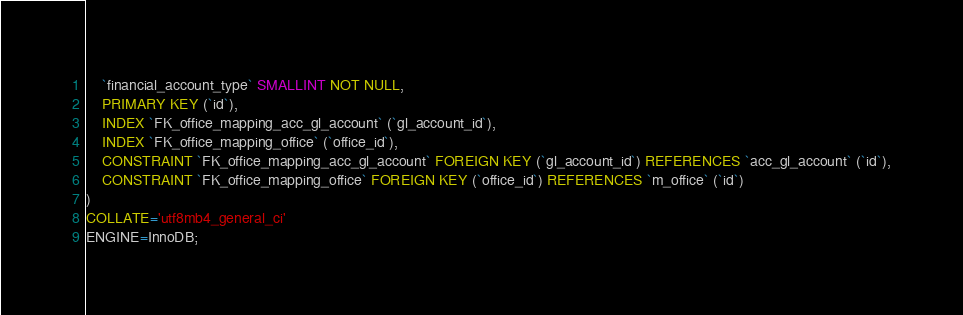Convert code to text. <code><loc_0><loc_0><loc_500><loc_500><_SQL_>	`financial_account_type` SMALLINT NOT NULL,
	PRIMARY KEY (`id`),
	INDEX `FK_office_mapping_acc_gl_account` (`gl_account_id`),
	INDEX `FK_office_mapping_office` (`office_id`),
	CONSTRAINT `FK_office_mapping_acc_gl_account` FOREIGN KEY (`gl_account_id`) REFERENCES `acc_gl_account` (`id`),
	CONSTRAINT `FK_office_mapping_office` FOREIGN KEY (`office_id`) REFERENCES `m_office` (`id`)
)
COLLATE='utf8mb4_general_ci'
ENGINE=InnoDB;
</code> 